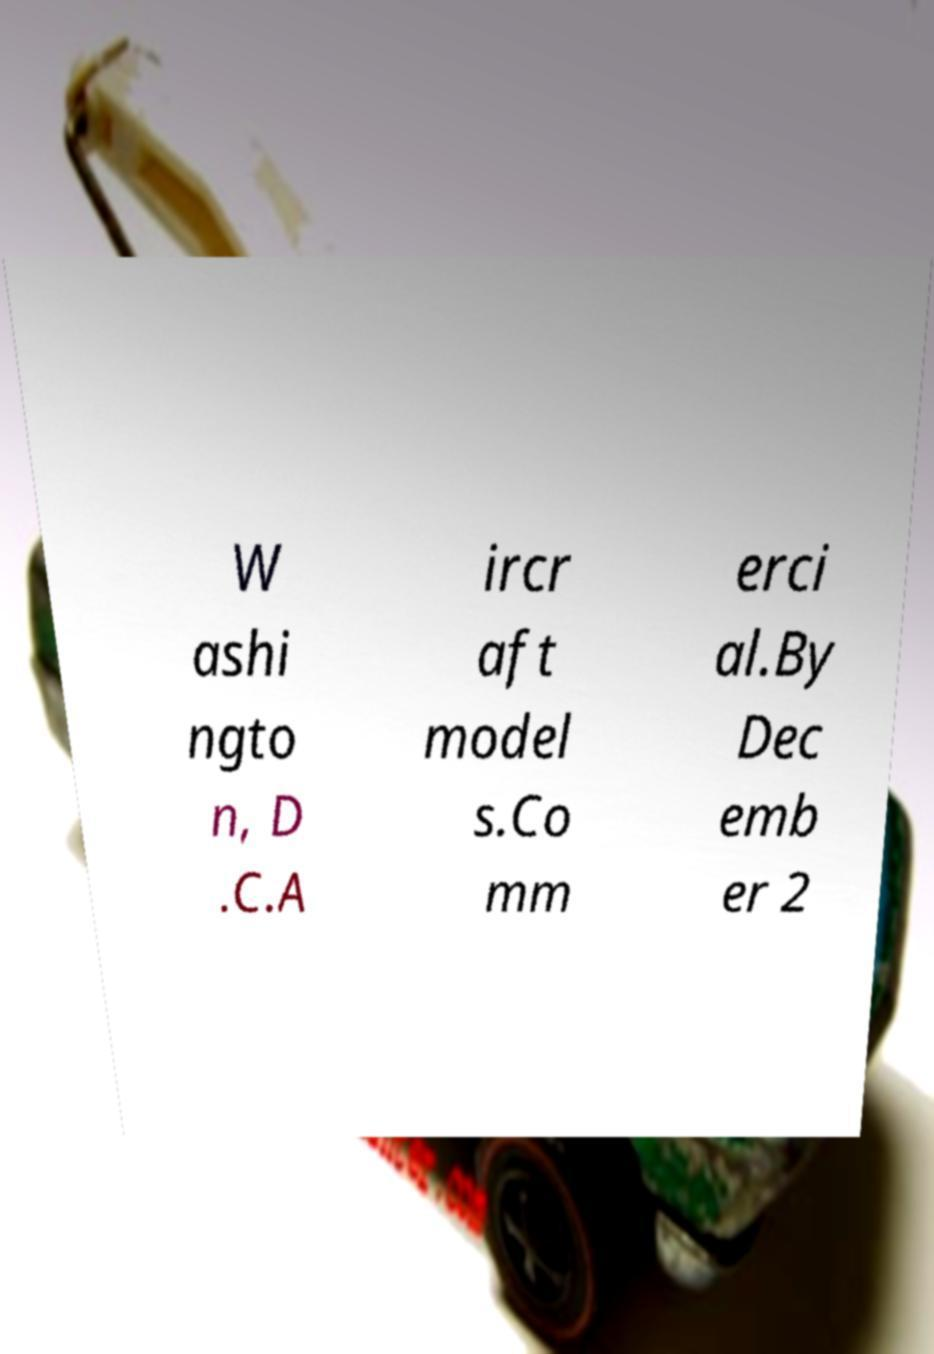Can you read and provide the text displayed in the image?This photo seems to have some interesting text. Can you extract and type it out for me? W ashi ngto n, D .C.A ircr aft model s.Co mm erci al.By Dec emb er 2 